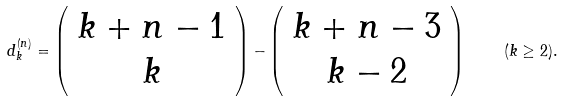Convert formula to latex. <formula><loc_0><loc_0><loc_500><loc_500>d _ { k } ^ { ( n ) } = \left ( \begin{array} { c } k + n - 1 \\ k \end{array} \right ) - \left ( \begin{array} { c } k + n - 3 \\ k - 2 \end{array} \right ) \quad ( k \geq 2 ) .</formula> 